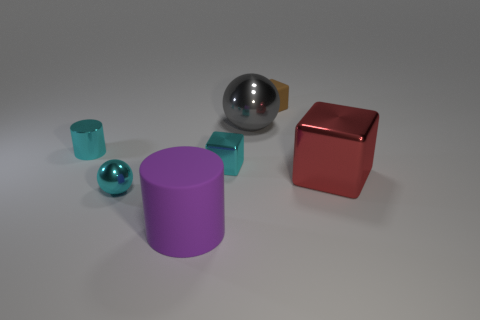Add 1 brown shiny things. How many objects exist? 8 Subtract all blocks. How many objects are left? 4 Add 7 blue cylinders. How many blue cylinders exist? 7 Subtract 0 red cylinders. How many objects are left? 7 Subtract all yellow matte cubes. Subtract all large purple cylinders. How many objects are left? 6 Add 6 large metal balls. How many large metal balls are left? 7 